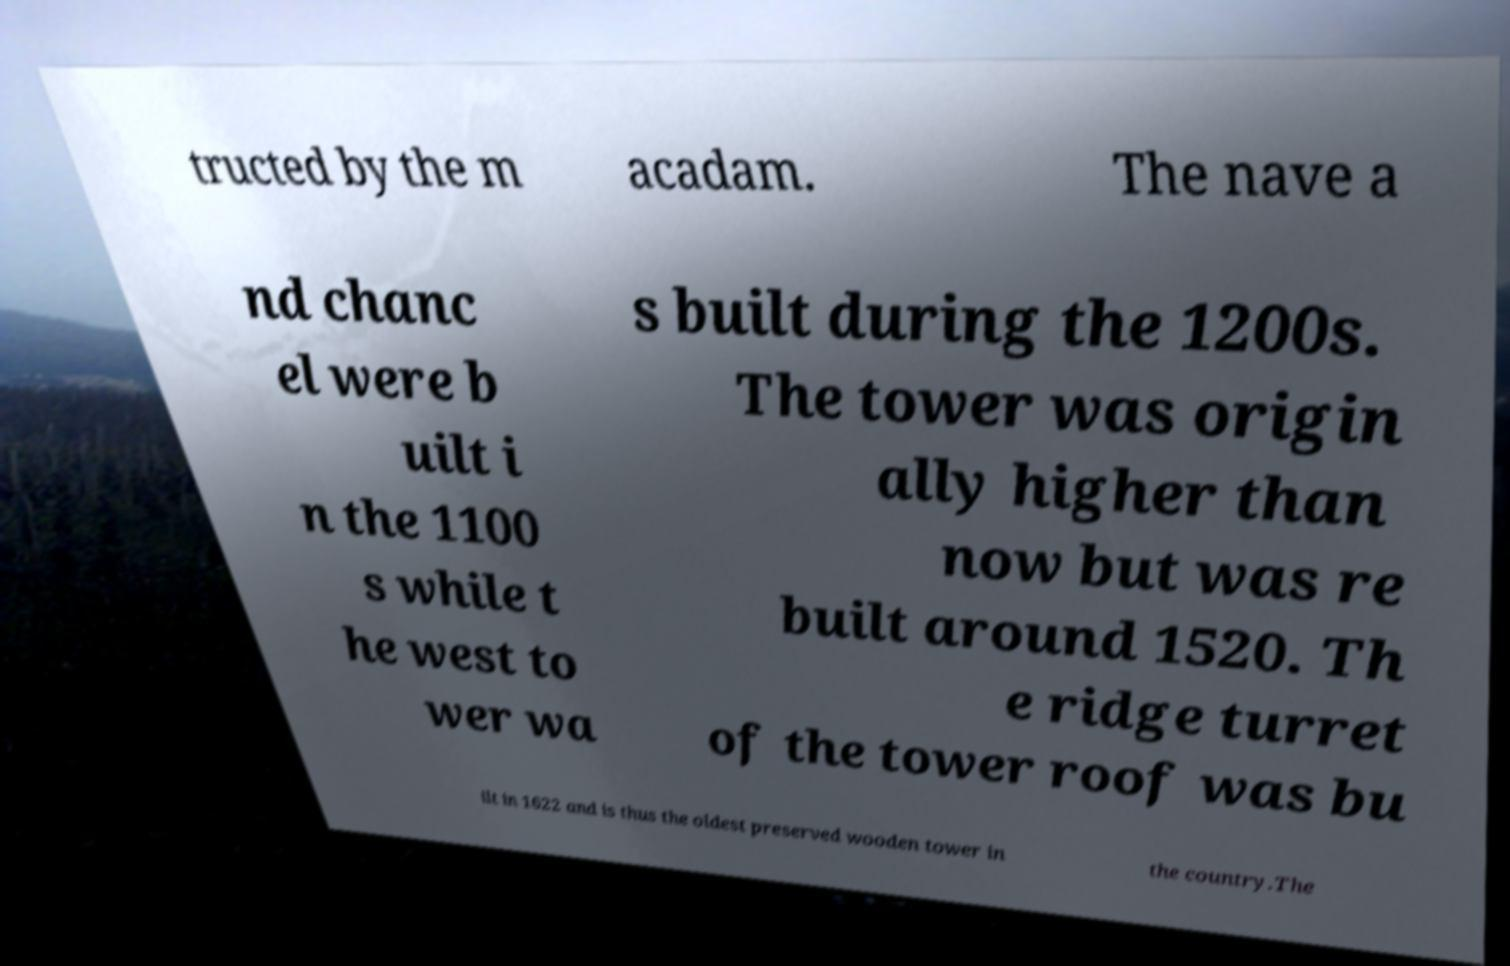Can you read and provide the text displayed in the image?This photo seems to have some interesting text. Can you extract and type it out for me? tructed by the m acadam. The nave a nd chanc el were b uilt i n the 1100 s while t he west to wer wa s built during the 1200s. The tower was origin ally higher than now but was re built around 1520. Th e ridge turret of the tower roof was bu ilt in 1622 and is thus the oldest preserved wooden tower in the country.The 